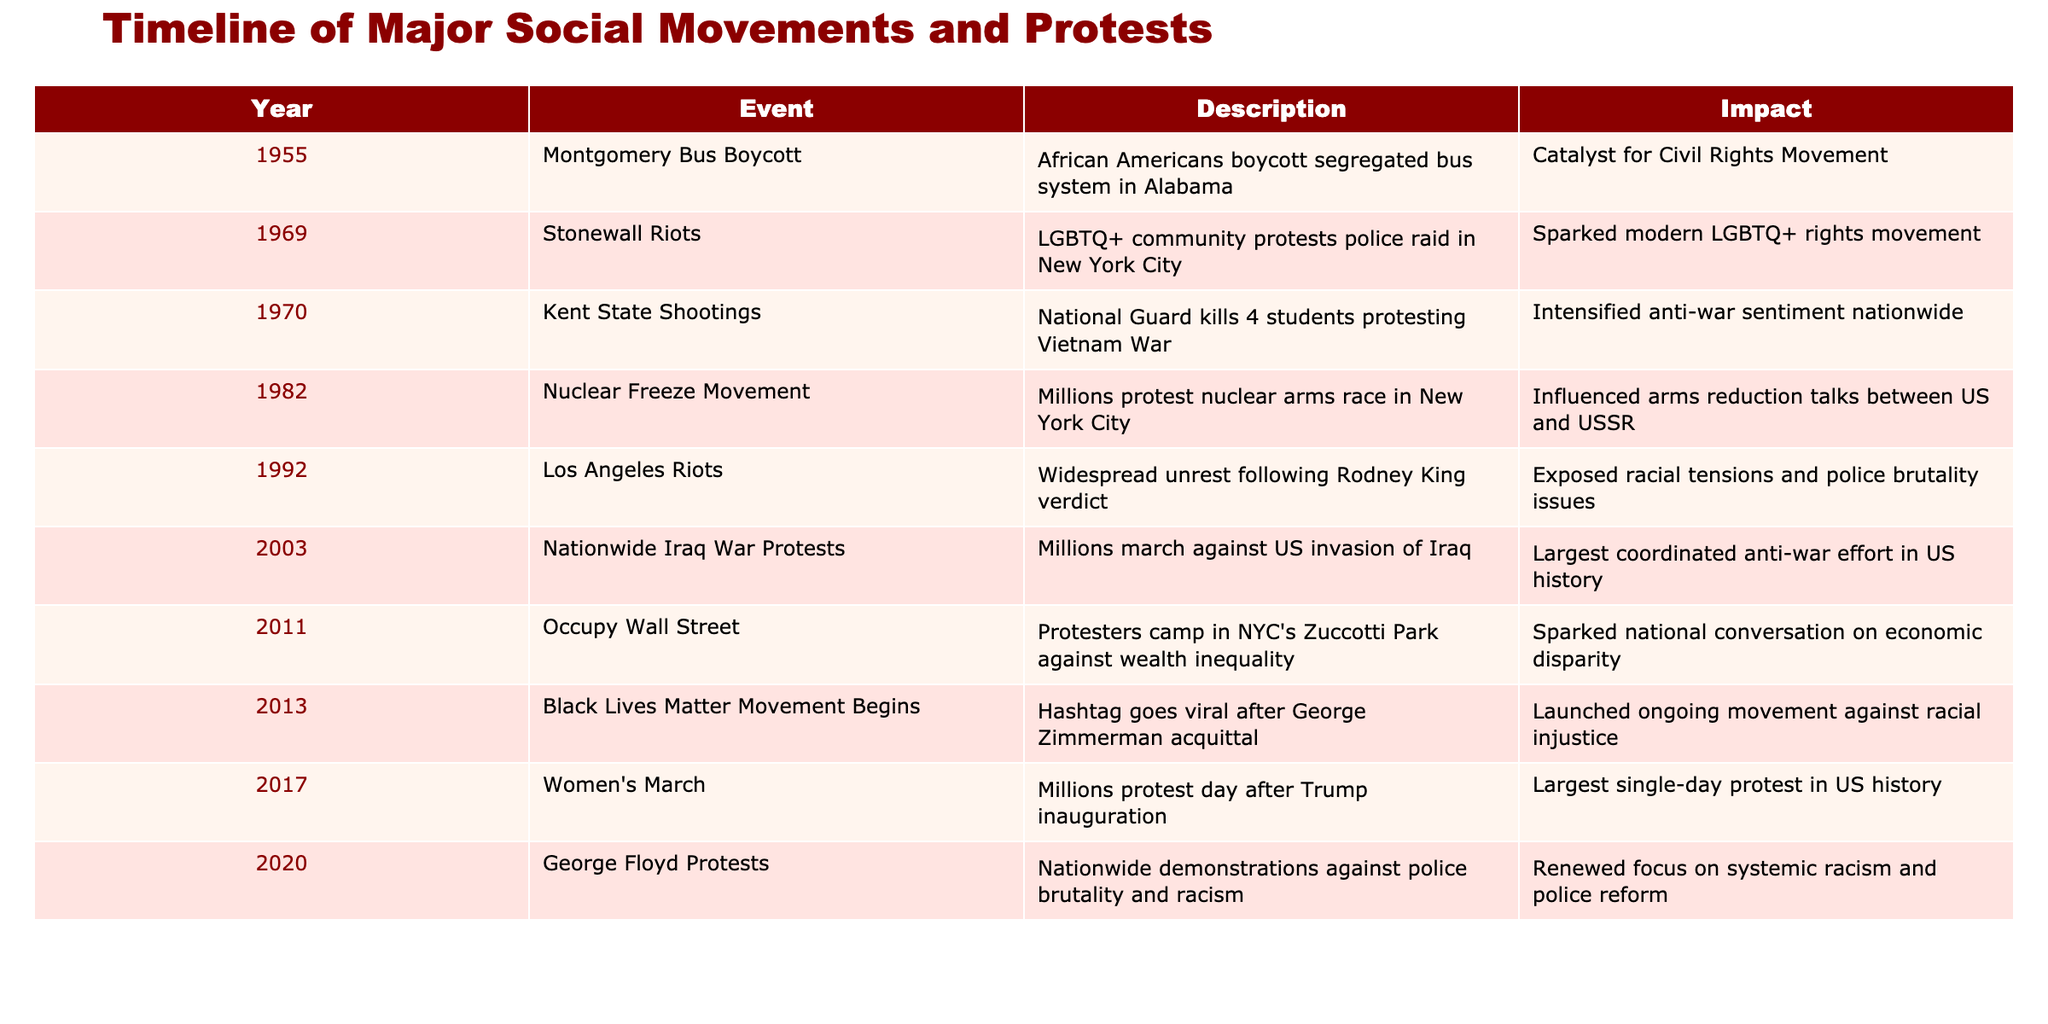What year did the Montgomery Bus Boycott occur? The table explicitly lists the year for the Montgomery Bus Boycott in the first row under the Year column, which shows 1955.
Answer: 1955 What was the main impact of the Women's March? Referring to the impact column associated with the Women's March entry, it states that it was the largest single-day protest in US history.
Answer: Largest single-day protest in US history How many events in total are listed in the table? By counting the number of rows in the table (not including the header), we can see there are ten events listed, confirming the total number is 10.
Answer: 10 Did any event occur in 2003, and what was its impact? By observing the year column, we find the Nationwide Iraq War Protests listed for 2003, with its impact noted as the largest coordinated anti-war effort in US history.
Answer: Yes, largest coordinated anti-war effort in US history Which two events had impacts related to police brutality? Looking for keywords in the impact column, the Los Angeles Riots in 1992 and the George Floyd Protests in 2020 both mention issues of police brutality, confirming these two events are related.
Answer: Los Angeles Riots and George Floyd Protests What is the difference in years between the Stonewall Riots and the Women's March? The Stonewall Riots occurred in 1969 and the Women's March in 2017. By subtracting 1969 from 2017, we find the difference is 48 years.
Answer: 48 years Was the Nuclear Freeze Movement a response to domestic or international issues? The Nuclear Freeze Movement was aimed at protesting the nuclear arms race between the US and USSR, indicating it was an international issue.
Answer: International issue Which event caused the most intensity in anti-war sentiment? The table lists the Kent State Shootings in 1970, with its impact noted as having intensified anti-war sentiment nationwide, suggesting it is recognized as the most impactful in that regard.
Answer: Kent State Shootings How many events listed had more than one word in their titles? In scanning through the table, eight out of ten events have titles consisting of more than one word: Montgomery Bus Boycott, Stonewall Riots, Kent State Shootings, Nuclear Freeze Movement, Los Angeles Riots, Nationwide Iraq War Protests, Occupy Wall Street, and Women's March. Therefore, the answer can be calculated as 8.
Answer: 8 